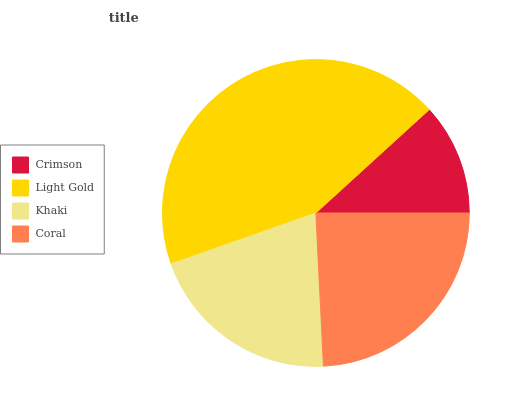Is Crimson the minimum?
Answer yes or no. Yes. Is Light Gold the maximum?
Answer yes or no. Yes. Is Khaki the minimum?
Answer yes or no. No. Is Khaki the maximum?
Answer yes or no. No. Is Light Gold greater than Khaki?
Answer yes or no. Yes. Is Khaki less than Light Gold?
Answer yes or no. Yes. Is Khaki greater than Light Gold?
Answer yes or no. No. Is Light Gold less than Khaki?
Answer yes or no. No. Is Coral the high median?
Answer yes or no. Yes. Is Khaki the low median?
Answer yes or no. Yes. Is Light Gold the high median?
Answer yes or no. No. Is Light Gold the low median?
Answer yes or no. No. 